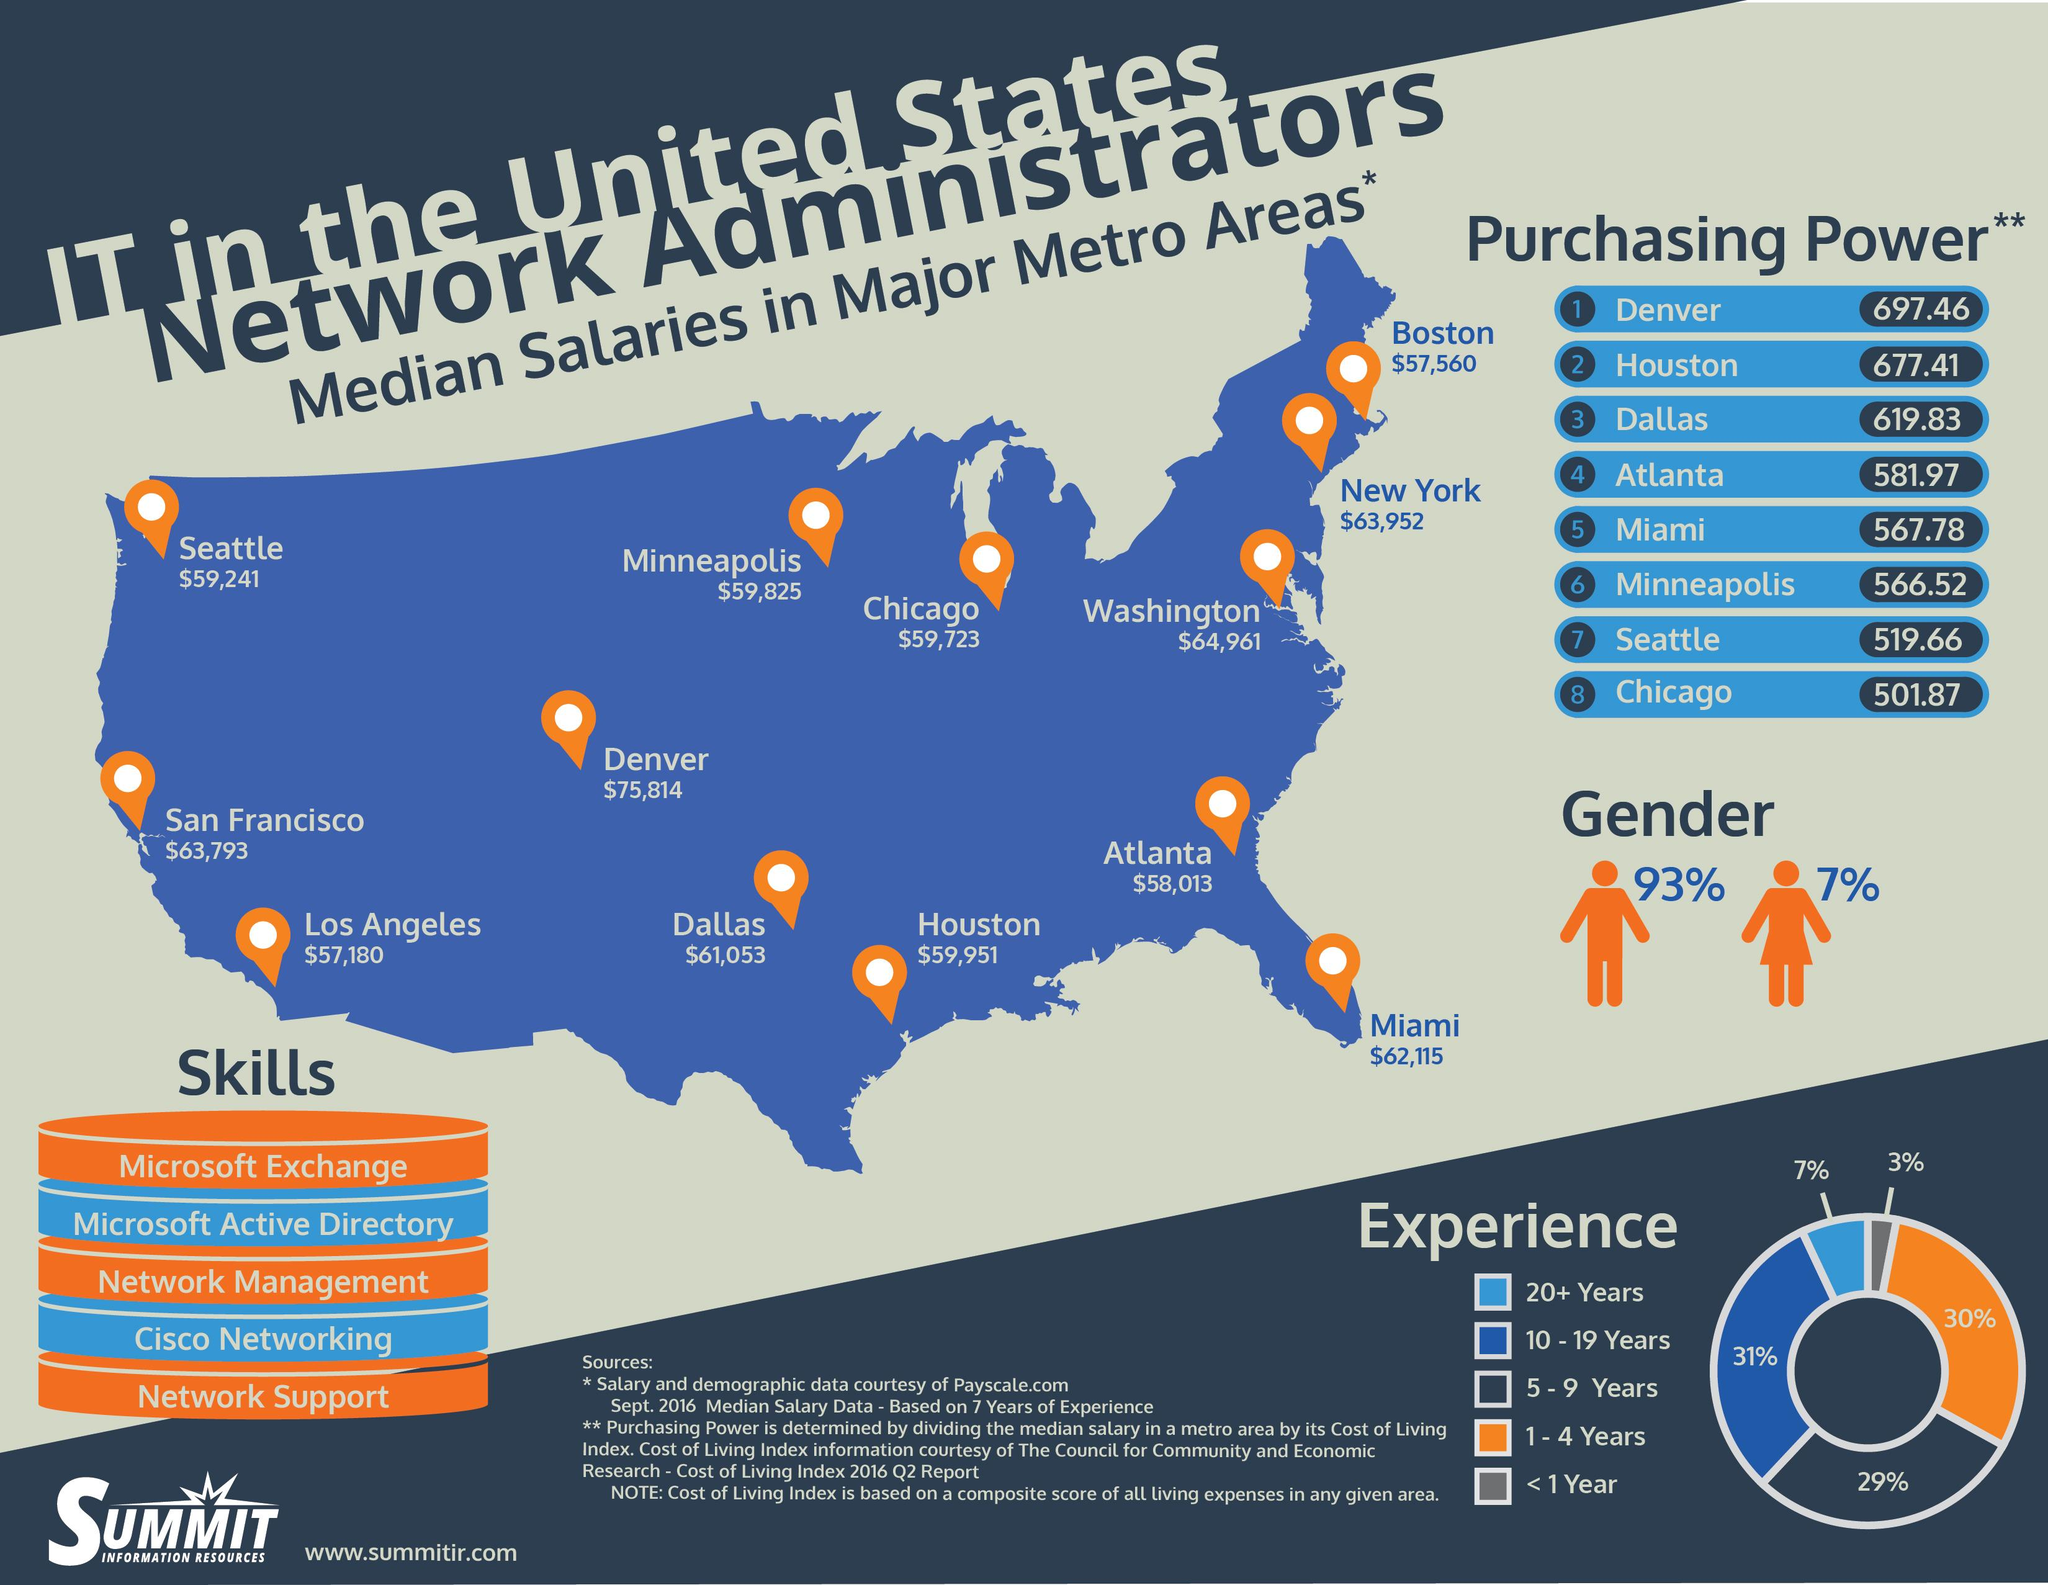Draw attention to some important aspects in this diagram. The median salary of network administrators in New York is $63,952. According to data, the city in the United States with the highest median salary for network administrators is Denver. According to a recent survey, approximately 30% of people in the United States have 1-4 years of experience as a network administrator. According to a recent survey, only 7% of people in the United States have 20 or more years of experience as a network administrator. The median salary of network administrators in Chicago is $59,723. 